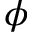Convert formula to latex. <formula><loc_0><loc_0><loc_500><loc_500>\phi</formula> 